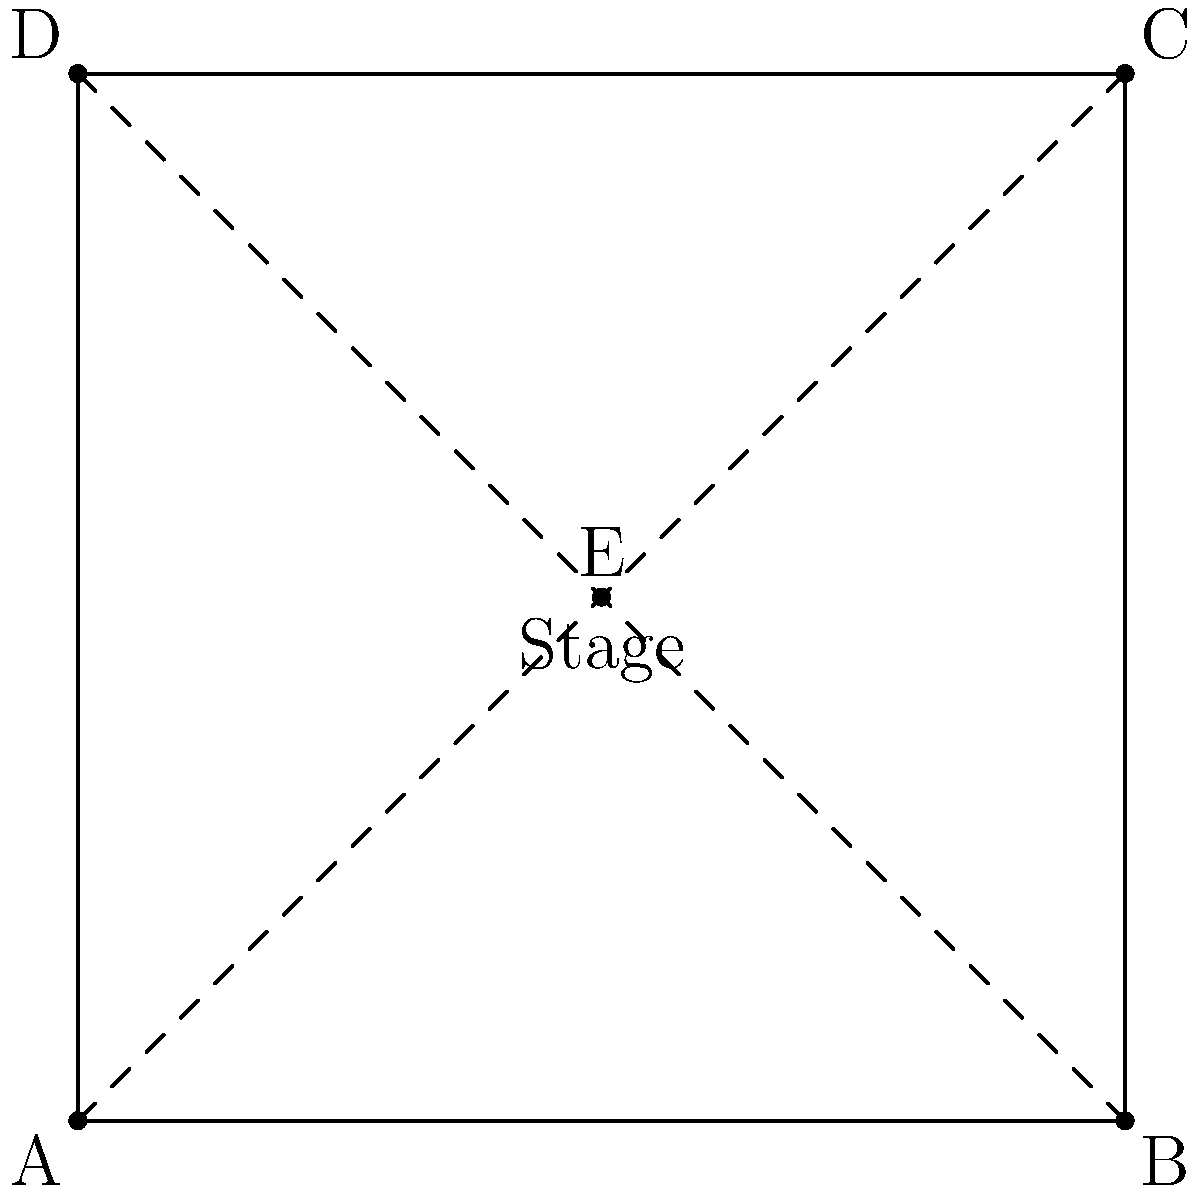As a singer-songwriter preparing for an open mic night, you're planning the stage positions for your band. The stage is represented by the square ABCD, with E at the center. If you start at point A and want to end up at point C, which combination of transformations would achieve this while ensuring you pass through the center point E? Express your answer as a sequence of transformations. Let's approach this step-by-step:

1) First, we need to move from point A to the center point E. This can be achieved by a translation.
   - The vector for this translation is $\vec{AE} = (2,2)$

2) Next, we need to move from point E to point C. This can be seen as a rotation around point E.
   - The rotation is 180° (or $\pi$ radians) clockwise around point E

3) We can express this as a sequence of two transformations:
   a) Translation by vector $(2,2)$
   b) Rotation by 180° around point E

4) In transformational geometry, we typically write the sequence of transformations from right to left. So our final answer would be:

   Rotation$_{E,180°}$ ∘ Translation$_{(2,2)}$

Where ∘ represents the composition of transformations.
Answer: Rotation$_{E,180°}$ ∘ Translation$_{(2,2)}$ 